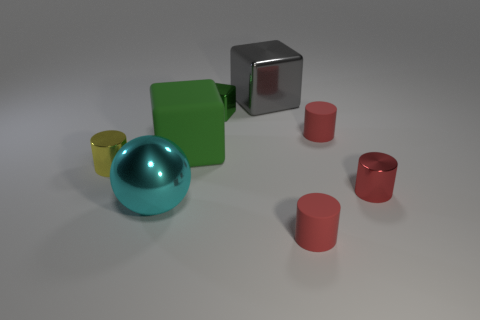Add 1 tiny cyan objects. How many objects exist? 9 Subtract all yellow cylinders. How many cylinders are left? 3 Subtract all small yellow cylinders. How many cylinders are left? 3 Subtract all cubes. How many objects are left? 5 Subtract 3 cylinders. How many cylinders are left? 1 Subtract all green cylinders. Subtract all blue blocks. How many cylinders are left? 4 Subtract all green spheres. How many gray cylinders are left? 0 Subtract all large metallic things. Subtract all small red matte cylinders. How many objects are left? 4 Add 6 matte cylinders. How many matte cylinders are left? 8 Add 7 gray cubes. How many gray cubes exist? 8 